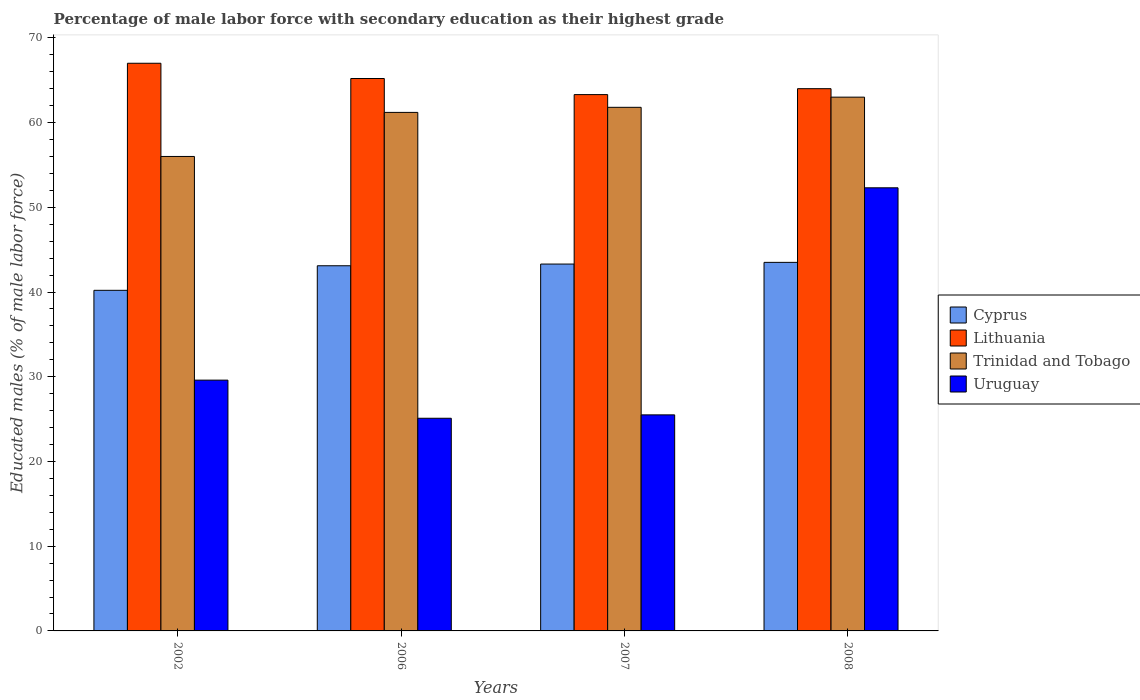How many different coloured bars are there?
Offer a terse response. 4. Are the number of bars on each tick of the X-axis equal?
Make the answer very short. Yes. Across all years, what is the maximum percentage of male labor force with secondary education in Lithuania?
Your answer should be very brief. 67. Across all years, what is the minimum percentage of male labor force with secondary education in Cyprus?
Your answer should be very brief. 40.2. In which year was the percentage of male labor force with secondary education in Cyprus maximum?
Offer a terse response. 2008. What is the total percentage of male labor force with secondary education in Uruguay in the graph?
Your response must be concise. 132.5. What is the difference between the percentage of male labor force with secondary education in Lithuania in 2002 and that in 2008?
Offer a very short reply. 3. What is the difference between the percentage of male labor force with secondary education in Trinidad and Tobago in 2007 and the percentage of male labor force with secondary education in Cyprus in 2002?
Ensure brevity in your answer.  21.6. What is the average percentage of male labor force with secondary education in Uruguay per year?
Keep it short and to the point. 33.12. In the year 2007, what is the difference between the percentage of male labor force with secondary education in Uruguay and percentage of male labor force with secondary education in Lithuania?
Ensure brevity in your answer.  -37.8. In how many years, is the percentage of male labor force with secondary education in Uruguay greater than 10 %?
Your response must be concise. 4. What is the ratio of the percentage of male labor force with secondary education in Lithuania in 2002 to that in 2008?
Your answer should be very brief. 1.05. Is the difference between the percentage of male labor force with secondary education in Uruguay in 2002 and 2007 greater than the difference between the percentage of male labor force with secondary education in Lithuania in 2002 and 2007?
Provide a succinct answer. Yes. What is the difference between the highest and the second highest percentage of male labor force with secondary education in Cyprus?
Keep it short and to the point. 0.2. What is the difference between the highest and the lowest percentage of male labor force with secondary education in Trinidad and Tobago?
Offer a very short reply. 7. In how many years, is the percentage of male labor force with secondary education in Trinidad and Tobago greater than the average percentage of male labor force with secondary education in Trinidad and Tobago taken over all years?
Provide a short and direct response. 3. Is it the case that in every year, the sum of the percentage of male labor force with secondary education in Lithuania and percentage of male labor force with secondary education in Cyprus is greater than the sum of percentage of male labor force with secondary education in Trinidad and Tobago and percentage of male labor force with secondary education in Uruguay?
Provide a succinct answer. No. What does the 3rd bar from the left in 2002 represents?
Provide a short and direct response. Trinidad and Tobago. What does the 4th bar from the right in 2007 represents?
Your answer should be very brief. Cyprus. Is it the case that in every year, the sum of the percentage of male labor force with secondary education in Lithuania and percentage of male labor force with secondary education in Uruguay is greater than the percentage of male labor force with secondary education in Trinidad and Tobago?
Your response must be concise. Yes. How many bars are there?
Make the answer very short. 16. Are all the bars in the graph horizontal?
Make the answer very short. No. What is the difference between two consecutive major ticks on the Y-axis?
Provide a succinct answer. 10. Are the values on the major ticks of Y-axis written in scientific E-notation?
Give a very brief answer. No. Does the graph contain any zero values?
Give a very brief answer. No. Does the graph contain grids?
Make the answer very short. No. How many legend labels are there?
Give a very brief answer. 4. How are the legend labels stacked?
Offer a very short reply. Vertical. What is the title of the graph?
Give a very brief answer. Percentage of male labor force with secondary education as their highest grade. What is the label or title of the Y-axis?
Your answer should be very brief. Educated males (% of male labor force). What is the Educated males (% of male labor force) in Cyprus in 2002?
Your answer should be very brief. 40.2. What is the Educated males (% of male labor force) of Uruguay in 2002?
Your answer should be compact. 29.6. What is the Educated males (% of male labor force) in Cyprus in 2006?
Keep it short and to the point. 43.1. What is the Educated males (% of male labor force) in Lithuania in 2006?
Your answer should be very brief. 65.2. What is the Educated males (% of male labor force) in Trinidad and Tobago in 2006?
Offer a terse response. 61.2. What is the Educated males (% of male labor force) of Uruguay in 2006?
Give a very brief answer. 25.1. What is the Educated males (% of male labor force) in Cyprus in 2007?
Your answer should be compact. 43.3. What is the Educated males (% of male labor force) in Lithuania in 2007?
Make the answer very short. 63.3. What is the Educated males (% of male labor force) in Trinidad and Tobago in 2007?
Give a very brief answer. 61.8. What is the Educated males (% of male labor force) of Cyprus in 2008?
Your response must be concise. 43.5. What is the Educated males (% of male labor force) of Trinidad and Tobago in 2008?
Offer a terse response. 63. What is the Educated males (% of male labor force) of Uruguay in 2008?
Your answer should be compact. 52.3. Across all years, what is the maximum Educated males (% of male labor force) in Cyprus?
Offer a very short reply. 43.5. Across all years, what is the maximum Educated males (% of male labor force) of Lithuania?
Your answer should be compact. 67. Across all years, what is the maximum Educated males (% of male labor force) of Uruguay?
Make the answer very short. 52.3. Across all years, what is the minimum Educated males (% of male labor force) of Cyprus?
Provide a succinct answer. 40.2. Across all years, what is the minimum Educated males (% of male labor force) of Lithuania?
Offer a terse response. 63.3. Across all years, what is the minimum Educated males (% of male labor force) of Uruguay?
Ensure brevity in your answer.  25.1. What is the total Educated males (% of male labor force) in Cyprus in the graph?
Make the answer very short. 170.1. What is the total Educated males (% of male labor force) of Lithuania in the graph?
Provide a succinct answer. 259.5. What is the total Educated males (% of male labor force) of Trinidad and Tobago in the graph?
Give a very brief answer. 242. What is the total Educated males (% of male labor force) of Uruguay in the graph?
Give a very brief answer. 132.5. What is the difference between the Educated males (% of male labor force) in Cyprus in 2002 and that in 2006?
Your answer should be compact. -2.9. What is the difference between the Educated males (% of male labor force) in Uruguay in 2002 and that in 2006?
Make the answer very short. 4.5. What is the difference between the Educated males (% of male labor force) in Lithuania in 2002 and that in 2007?
Give a very brief answer. 3.7. What is the difference between the Educated males (% of male labor force) in Uruguay in 2002 and that in 2007?
Your answer should be compact. 4.1. What is the difference between the Educated males (% of male labor force) of Trinidad and Tobago in 2002 and that in 2008?
Offer a very short reply. -7. What is the difference between the Educated males (% of male labor force) in Uruguay in 2002 and that in 2008?
Offer a terse response. -22.7. What is the difference between the Educated males (% of male labor force) of Trinidad and Tobago in 2006 and that in 2007?
Offer a very short reply. -0.6. What is the difference between the Educated males (% of male labor force) of Uruguay in 2006 and that in 2007?
Your answer should be compact. -0.4. What is the difference between the Educated males (% of male labor force) of Cyprus in 2006 and that in 2008?
Make the answer very short. -0.4. What is the difference between the Educated males (% of male labor force) of Uruguay in 2006 and that in 2008?
Give a very brief answer. -27.2. What is the difference between the Educated males (% of male labor force) of Cyprus in 2007 and that in 2008?
Your answer should be very brief. -0.2. What is the difference between the Educated males (% of male labor force) in Lithuania in 2007 and that in 2008?
Your answer should be compact. -0.7. What is the difference between the Educated males (% of male labor force) of Trinidad and Tobago in 2007 and that in 2008?
Provide a short and direct response. -1.2. What is the difference between the Educated males (% of male labor force) in Uruguay in 2007 and that in 2008?
Give a very brief answer. -26.8. What is the difference between the Educated males (% of male labor force) in Cyprus in 2002 and the Educated males (% of male labor force) in Lithuania in 2006?
Your response must be concise. -25. What is the difference between the Educated males (% of male labor force) in Lithuania in 2002 and the Educated males (% of male labor force) in Uruguay in 2006?
Make the answer very short. 41.9. What is the difference between the Educated males (% of male labor force) in Trinidad and Tobago in 2002 and the Educated males (% of male labor force) in Uruguay in 2006?
Your response must be concise. 30.9. What is the difference between the Educated males (% of male labor force) of Cyprus in 2002 and the Educated males (% of male labor force) of Lithuania in 2007?
Give a very brief answer. -23.1. What is the difference between the Educated males (% of male labor force) of Cyprus in 2002 and the Educated males (% of male labor force) of Trinidad and Tobago in 2007?
Provide a short and direct response. -21.6. What is the difference between the Educated males (% of male labor force) of Cyprus in 2002 and the Educated males (% of male labor force) of Uruguay in 2007?
Offer a terse response. 14.7. What is the difference between the Educated males (% of male labor force) in Lithuania in 2002 and the Educated males (% of male labor force) in Uruguay in 2007?
Your answer should be very brief. 41.5. What is the difference between the Educated males (% of male labor force) of Trinidad and Tobago in 2002 and the Educated males (% of male labor force) of Uruguay in 2007?
Give a very brief answer. 30.5. What is the difference between the Educated males (% of male labor force) of Cyprus in 2002 and the Educated males (% of male labor force) of Lithuania in 2008?
Your response must be concise. -23.8. What is the difference between the Educated males (% of male labor force) of Cyprus in 2002 and the Educated males (% of male labor force) of Trinidad and Tobago in 2008?
Provide a succinct answer. -22.8. What is the difference between the Educated males (% of male labor force) in Lithuania in 2002 and the Educated males (% of male labor force) in Trinidad and Tobago in 2008?
Your answer should be compact. 4. What is the difference between the Educated males (% of male labor force) in Trinidad and Tobago in 2002 and the Educated males (% of male labor force) in Uruguay in 2008?
Offer a very short reply. 3.7. What is the difference between the Educated males (% of male labor force) in Cyprus in 2006 and the Educated males (% of male labor force) in Lithuania in 2007?
Offer a very short reply. -20.2. What is the difference between the Educated males (% of male labor force) of Cyprus in 2006 and the Educated males (% of male labor force) of Trinidad and Tobago in 2007?
Make the answer very short. -18.7. What is the difference between the Educated males (% of male labor force) of Lithuania in 2006 and the Educated males (% of male labor force) of Uruguay in 2007?
Ensure brevity in your answer.  39.7. What is the difference between the Educated males (% of male labor force) in Trinidad and Tobago in 2006 and the Educated males (% of male labor force) in Uruguay in 2007?
Keep it short and to the point. 35.7. What is the difference between the Educated males (% of male labor force) in Cyprus in 2006 and the Educated males (% of male labor force) in Lithuania in 2008?
Offer a terse response. -20.9. What is the difference between the Educated males (% of male labor force) in Cyprus in 2006 and the Educated males (% of male labor force) in Trinidad and Tobago in 2008?
Provide a short and direct response. -19.9. What is the difference between the Educated males (% of male labor force) in Trinidad and Tobago in 2006 and the Educated males (% of male labor force) in Uruguay in 2008?
Offer a very short reply. 8.9. What is the difference between the Educated males (% of male labor force) of Cyprus in 2007 and the Educated males (% of male labor force) of Lithuania in 2008?
Keep it short and to the point. -20.7. What is the difference between the Educated males (% of male labor force) of Cyprus in 2007 and the Educated males (% of male labor force) of Trinidad and Tobago in 2008?
Your answer should be compact. -19.7. What is the average Educated males (% of male labor force) of Cyprus per year?
Your answer should be compact. 42.52. What is the average Educated males (% of male labor force) of Lithuania per year?
Make the answer very short. 64.88. What is the average Educated males (% of male labor force) in Trinidad and Tobago per year?
Your response must be concise. 60.5. What is the average Educated males (% of male labor force) in Uruguay per year?
Your answer should be very brief. 33.12. In the year 2002, what is the difference between the Educated males (% of male labor force) of Cyprus and Educated males (% of male labor force) of Lithuania?
Ensure brevity in your answer.  -26.8. In the year 2002, what is the difference between the Educated males (% of male labor force) of Cyprus and Educated males (% of male labor force) of Trinidad and Tobago?
Provide a short and direct response. -15.8. In the year 2002, what is the difference between the Educated males (% of male labor force) in Lithuania and Educated males (% of male labor force) in Trinidad and Tobago?
Make the answer very short. 11. In the year 2002, what is the difference between the Educated males (% of male labor force) of Lithuania and Educated males (% of male labor force) of Uruguay?
Provide a succinct answer. 37.4. In the year 2002, what is the difference between the Educated males (% of male labor force) in Trinidad and Tobago and Educated males (% of male labor force) in Uruguay?
Your answer should be very brief. 26.4. In the year 2006, what is the difference between the Educated males (% of male labor force) in Cyprus and Educated males (% of male labor force) in Lithuania?
Your answer should be compact. -22.1. In the year 2006, what is the difference between the Educated males (% of male labor force) of Cyprus and Educated males (% of male labor force) of Trinidad and Tobago?
Provide a short and direct response. -18.1. In the year 2006, what is the difference between the Educated males (% of male labor force) in Cyprus and Educated males (% of male labor force) in Uruguay?
Keep it short and to the point. 18. In the year 2006, what is the difference between the Educated males (% of male labor force) of Lithuania and Educated males (% of male labor force) of Trinidad and Tobago?
Offer a very short reply. 4. In the year 2006, what is the difference between the Educated males (% of male labor force) in Lithuania and Educated males (% of male labor force) in Uruguay?
Keep it short and to the point. 40.1. In the year 2006, what is the difference between the Educated males (% of male labor force) in Trinidad and Tobago and Educated males (% of male labor force) in Uruguay?
Offer a terse response. 36.1. In the year 2007, what is the difference between the Educated males (% of male labor force) in Cyprus and Educated males (% of male labor force) in Lithuania?
Offer a terse response. -20. In the year 2007, what is the difference between the Educated males (% of male labor force) of Cyprus and Educated males (% of male labor force) of Trinidad and Tobago?
Your response must be concise. -18.5. In the year 2007, what is the difference between the Educated males (% of male labor force) in Cyprus and Educated males (% of male labor force) in Uruguay?
Give a very brief answer. 17.8. In the year 2007, what is the difference between the Educated males (% of male labor force) in Lithuania and Educated males (% of male labor force) in Trinidad and Tobago?
Make the answer very short. 1.5. In the year 2007, what is the difference between the Educated males (% of male labor force) of Lithuania and Educated males (% of male labor force) of Uruguay?
Your response must be concise. 37.8. In the year 2007, what is the difference between the Educated males (% of male labor force) of Trinidad and Tobago and Educated males (% of male labor force) of Uruguay?
Your response must be concise. 36.3. In the year 2008, what is the difference between the Educated males (% of male labor force) in Cyprus and Educated males (% of male labor force) in Lithuania?
Your answer should be compact. -20.5. In the year 2008, what is the difference between the Educated males (% of male labor force) in Cyprus and Educated males (% of male labor force) in Trinidad and Tobago?
Your answer should be compact. -19.5. In the year 2008, what is the difference between the Educated males (% of male labor force) of Cyprus and Educated males (% of male labor force) of Uruguay?
Ensure brevity in your answer.  -8.8. In the year 2008, what is the difference between the Educated males (% of male labor force) in Lithuania and Educated males (% of male labor force) in Uruguay?
Ensure brevity in your answer.  11.7. In the year 2008, what is the difference between the Educated males (% of male labor force) of Trinidad and Tobago and Educated males (% of male labor force) of Uruguay?
Give a very brief answer. 10.7. What is the ratio of the Educated males (% of male labor force) in Cyprus in 2002 to that in 2006?
Your response must be concise. 0.93. What is the ratio of the Educated males (% of male labor force) in Lithuania in 2002 to that in 2006?
Offer a very short reply. 1.03. What is the ratio of the Educated males (% of male labor force) of Trinidad and Tobago in 2002 to that in 2006?
Offer a terse response. 0.92. What is the ratio of the Educated males (% of male labor force) in Uruguay in 2002 to that in 2006?
Your response must be concise. 1.18. What is the ratio of the Educated males (% of male labor force) in Cyprus in 2002 to that in 2007?
Your answer should be compact. 0.93. What is the ratio of the Educated males (% of male labor force) of Lithuania in 2002 to that in 2007?
Your answer should be compact. 1.06. What is the ratio of the Educated males (% of male labor force) of Trinidad and Tobago in 2002 to that in 2007?
Your answer should be very brief. 0.91. What is the ratio of the Educated males (% of male labor force) of Uruguay in 2002 to that in 2007?
Provide a succinct answer. 1.16. What is the ratio of the Educated males (% of male labor force) in Cyprus in 2002 to that in 2008?
Provide a short and direct response. 0.92. What is the ratio of the Educated males (% of male labor force) of Lithuania in 2002 to that in 2008?
Offer a terse response. 1.05. What is the ratio of the Educated males (% of male labor force) of Uruguay in 2002 to that in 2008?
Keep it short and to the point. 0.57. What is the ratio of the Educated males (% of male labor force) in Cyprus in 2006 to that in 2007?
Your answer should be compact. 1. What is the ratio of the Educated males (% of male labor force) in Lithuania in 2006 to that in 2007?
Make the answer very short. 1.03. What is the ratio of the Educated males (% of male labor force) in Trinidad and Tobago in 2006 to that in 2007?
Offer a very short reply. 0.99. What is the ratio of the Educated males (% of male labor force) in Uruguay in 2006 to that in 2007?
Offer a very short reply. 0.98. What is the ratio of the Educated males (% of male labor force) of Lithuania in 2006 to that in 2008?
Ensure brevity in your answer.  1.02. What is the ratio of the Educated males (% of male labor force) in Trinidad and Tobago in 2006 to that in 2008?
Offer a very short reply. 0.97. What is the ratio of the Educated males (% of male labor force) of Uruguay in 2006 to that in 2008?
Ensure brevity in your answer.  0.48. What is the ratio of the Educated males (% of male labor force) of Trinidad and Tobago in 2007 to that in 2008?
Ensure brevity in your answer.  0.98. What is the ratio of the Educated males (% of male labor force) of Uruguay in 2007 to that in 2008?
Ensure brevity in your answer.  0.49. What is the difference between the highest and the second highest Educated males (% of male labor force) in Lithuania?
Your answer should be very brief. 1.8. What is the difference between the highest and the second highest Educated males (% of male labor force) in Trinidad and Tobago?
Provide a succinct answer. 1.2. What is the difference between the highest and the second highest Educated males (% of male labor force) of Uruguay?
Your answer should be very brief. 22.7. What is the difference between the highest and the lowest Educated males (% of male labor force) of Lithuania?
Your answer should be very brief. 3.7. What is the difference between the highest and the lowest Educated males (% of male labor force) in Trinidad and Tobago?
Make the answer very short. 7. What is the difference between the highest and the lowest Educated males (% of male labor force) in Uruguay?
Provide a succinct answer. 27.2. 